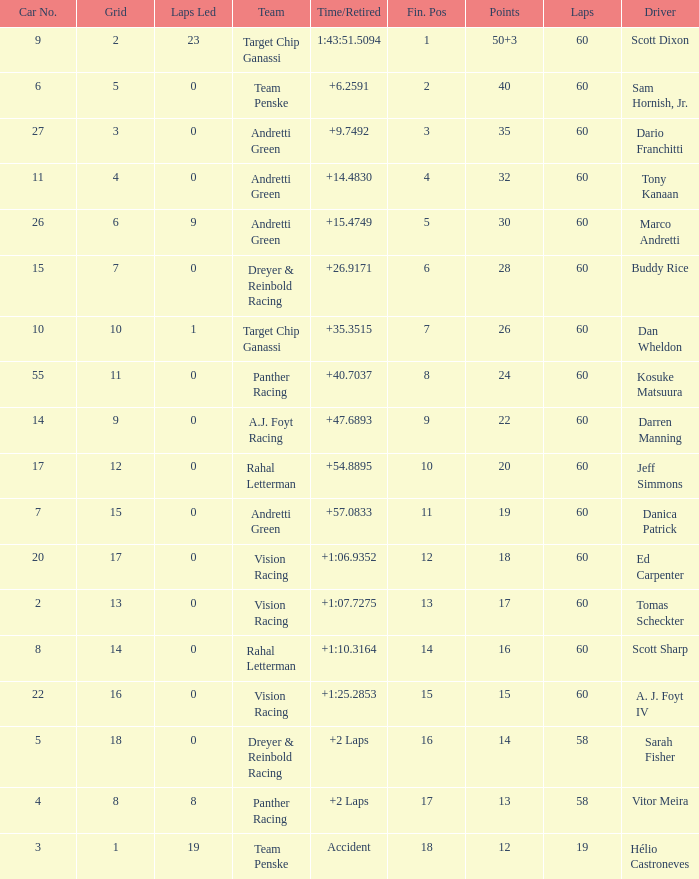Name the team for scott dixon Target Chip Ganassi. 